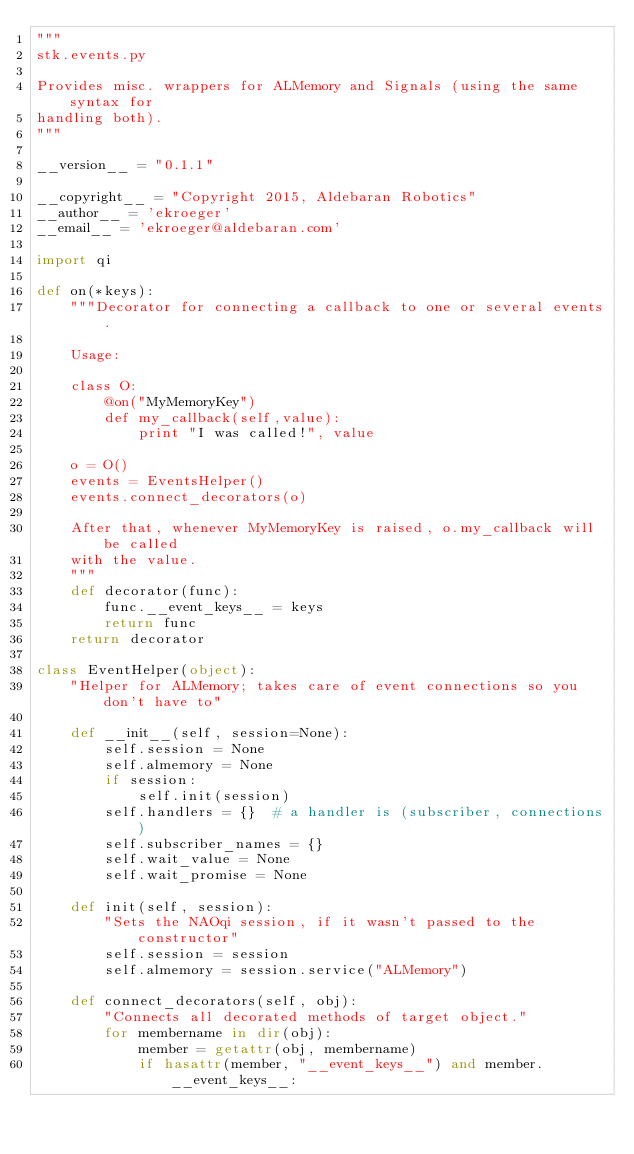Convert code to text. <code><loc_0><loc_0><loc_500><loc_500><_Python_>"""
stk.events.py

Provides misc. wrappers for ALMemory and Signals (using the same syntax for
handling both).
"""

__version__ = "0.1.1"

__copyright__ = "Copyright 2015, Aldebaran Robotics"
__author__ = 'ekroeger'
__email__ = 'ekroeger@aldebaran.com'

import qi

def on(*keys):
    """Decorator for connecting a callback to one or several events.

    Usage:

    class O:
        @on("MyMemoryKey")
        def my_callback(self,value):
            print "I was called!", value

    o = O()
    events = EventsHelper()
    events.connect_decorators(o)

    After that, whenever MyMemoryKey is raised, o.my_callback will be called
    with the value.
    """
    def decorator(func):
        func.__event_keys__ = keys
        return func
    return decorator

class EventHelper(object):
    "Helper for ALMemory; takes care of event connections so you don't have to"

    def __init__(self, session=None):
        self.session = None
        self.almemory = None
        if session:
            self.init(session)
        self.handlers = {}  # a handler is (subscriber, connections)
        self.subscriber_names = {}
        self.wait_value = None
        self.wait_promise = None

    def init(self, session):
        "Sets the NAOqi session, if it wasn't passed to the constructor"
        self.session = session
        self.almemory = session.service("ALMemory")

    def connect_decorators(self, obj):
        "Connects all decorated methods of target object."
        for membername in dir(obj):
            member = getattr(obj, membername)
            if hasattr(member, "__event_keys__") and member.__event_keys__:</code> 